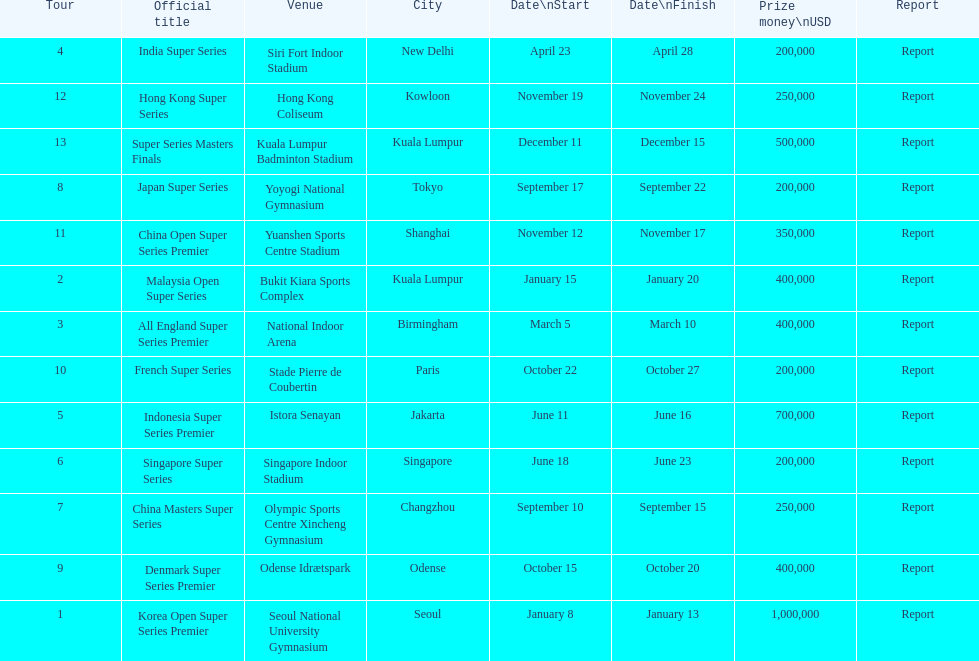In the 2013 bwf super series, how many events offer prize money exceeding $200,000? 9. 